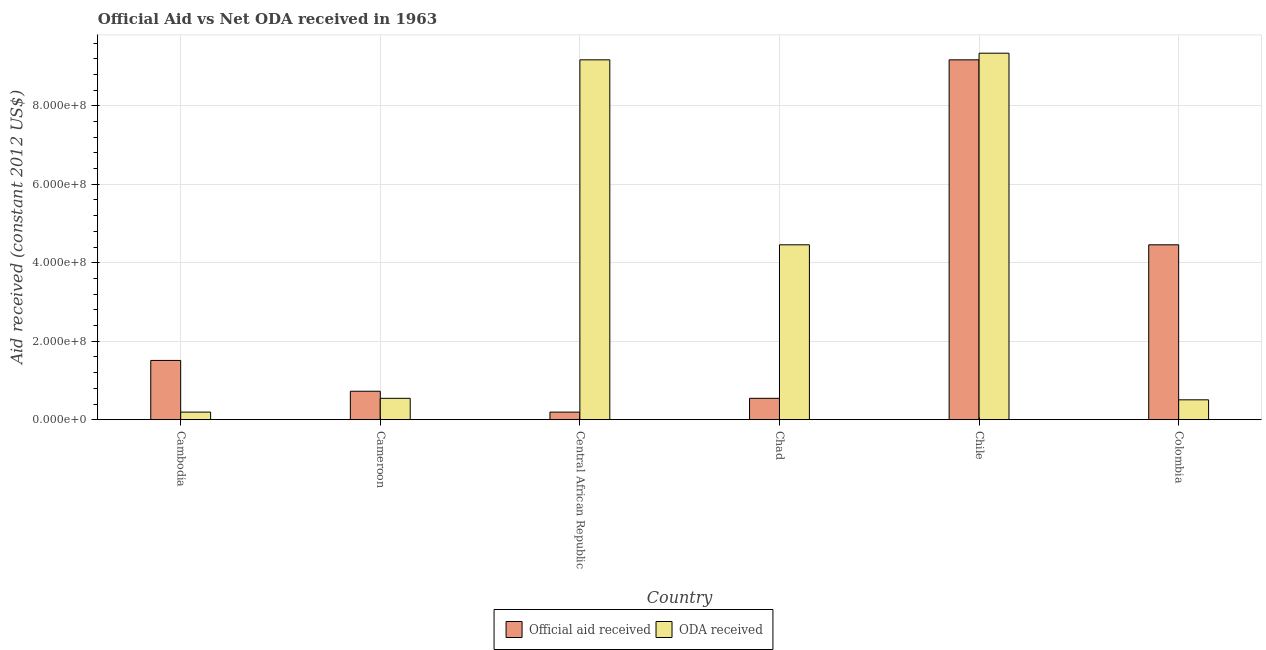How many different coloured bars are there?
Ensure brevity in your answer.  2. How many groups of bars are there?
Ensure brevity in your answer.  6. What is the label of the 4th group of bars from the left?
Keep it short and to the point. Chad. In how many cases, is the number of bars for a given country not equal to the number of legend labels?
Give a very brief answer. 0. What is the official aid received in Cambodia?
Make the answer very short. 1.51e+08. Across all countries, what is the maximum oda received?
Keep it short and to the point. 9.34e+08. Across all countries, what is the minimum official aid received?
Provide a succinct answer. 1.94e+07. In which country was the oda received maximum?
Offer a terse response. Chile. In which country was the official aid received minimum?
Your answer should be compact. Central African Republic. What is the total oda received in the graph?
Keep it short and to the point. 2.42e+09. What is the difference between the official aid received in Cambodia and that in Cameroon?
Your answer should be very brief. 7.85e+07. What is the difference between the oda received in Central African Republic and the official aid received in Colombia?
Provide a short and direct response. 4.71e+08. What is the average official aid received per country?
Your answer should be compact. 2.77e+08. What is the difference between the oda received and official aid received in Cambodia?
Give a very brief answer. -1.32e+08. What is the ratio of the oda received in Central African Republic to that in Chile?
Offer a terse response. 0.98. Is the difference between the official aid received in Central African Republic and Colombia greater than the difference between the oda received in Central African Republic and Colombia?
Your response must be concise. No. What is the difference between the highest and the second highest oda received?
Keep it short and to the point. 1.69e+07. What is the difference between the highest and the lowest official aid received?
Provide a short and direct response. 8.98e+08. In how many countries, is the official aid received greater than the average official aid received taken over all countries?
Provide a succinct answer. 2. Is the sum of the official aid received in Cambodia and Cameroon greater than the maximum oda received across all countries?
Ensure brevity in your answer.  No. What does the 1st bar from the left in Cambodia represents?
Offer a terse response. Official aid received. What does the 1st bar from the right in Central African Republic represents?
Give a very brief answer. ODA received. How many bars are there?
Offer a very short reply. 12. How many countries are there in the graph?
Keep it short and to the point. 6. What is the difference between two consecutive major ticks on the Y-axis?
Provide a short and direct response. 2.00e+08. Are the values on the major ticks of Y-axis written in scientific E-notation?
Offer a very short reply. Yes. Does the graph contain any zero values?
Your response must be concise. No. Does the graph contain grids?
Keep it short and to the point. Yes. Where does the legend appear in the graph?
Make the answer very short. Bottom center. How many legend labels are there?
Make the answer very short. 2. How are the legend labels stacked?
Ensure brevity in your answer.  Horizontal. What is the title of the graph?
Your answer should be compact. Official Aid vs Net ODA received in 1963 . What is the label or title of the X-axis?
Offer a very short reply. Country. What is the label or title of the Y-axis?
Your answer should be compact. Aid received (constant 2012 US$). What is the Aid received (constant 2012 US$) in Official aid received in Cambodia?
Offer a terse response. 1.51e+08. What is the Aid received (constant 2012 US$) of ODA received in Cambodia?
Offer a terse response. 1.94e+07. What is the Aid received (constant 2012 US$) of Official aid received in Cameroon?
Keep it short and to the point. 7.25e+07. What is the Aid received (constant 2012 US$) of ODA received in Cameroon?
Your response must be concise. 5.45e+07. What is the Aid received (constant 2012 US$) in Official aid received in Central African Republic?
Give a very brief answer. 1.94e+07. What is the Aid received (constant 2012 US$) in ODA received in Central African Republic?
Ensure brevity in your answer.  9.17e+08. What is the Aid received (constant 2012 US$) in Official aid received in Chad?
Your answer should be very brief. 5.45e+07. What is the Aid received (constant 2012 US$) in ODA received in Chad?
Give a very brief answer. 4.46e+08. What is the Aid received (constant 2012 US$) of Official aid received in Chile?
Keep it short and to the point. 9.17e+08. What is the Aid received (constant 2012 US$) of ODA received in Chile?
Ensure brevity in your answer.  9.34e+08. What is the Aid received (constant 2012 US$) of Official aid received in Colombia?
Offer a terse response. 4.46e+08. What is the Aid received (constant 2012 US$) in ODA received in Colombia?
Provide a succinct answer. 5.06e+07. Across all countries, what is the maximum Aid received (constant 2012 US$) in Official aid received?
Keep it short and to the point. 9.17e+08. Across all countries, what is the maximum Aid received (constant 2012 US$) in ODA received?
Make the answer very short. 9.34e+08. Across all countries, what is the minimum Aid received (constant 2012 US$) of Official aid received?
Ensure brevity in your answer.  1.94e+07. Across all countries, what is the minimum Aid received (constant 2012 US$) of ODA received?
Your answer should be very brief. 1.94e+07. What is the total Aid received (constant 2012 US$) of Official aid received in the graph?
Your answer should be compact. 1.66e+09. What is the total Aid received (constant 2012 US$) of ODA received in the graph?
Ensure brevity in your answer.  2.42e+09. What is the difference between the Aid received (constant 2012 US$) of Official aid received in Cambodia and that in Cameroon?
Your answer should be very brief. 7.85e+07. What is the difference between the Aid received (constant 2012 US$) in ODA received in Cambodia and that in Cameroon?
Provide a short and direct response. -3.51e+07. What is the difference between the Aid received (constant 2012 US$) of Official aid received in Cambodia and that in Central African Republic?
Your answer should be compact. 1.32e+08. What is the difference between the Aid received (constant 2012 US$) of ODA received in Cambodia and that in Central African Republic?
Make the answer very short. -8.98e+08. What is the difference between the Aid received (constant 2012 US$) in Official aid received in Cambodia and that in Chad?
Your answer should be very brief. 9.66e+07. What is the difference between the Aid received (constant 2012 US$) in ODA received in Cambodia and that in Chad?
Provide a short and direct response. -4.26e+08. What is the difference between the Aid received (constant 2012 US$) in Official aid received in Cambodia and that in Chile?
Keep it short and to the point. -7.66e+08. What is the difference between the Aid received (constant 2012 US$) in ODA received in Cambodia and that in Chile?
Keep it short and to the point. -9.15e+08. What is the difference between the Aid received (constant 2012 US$) in Official aid received in Cambodia and that in Colombia?
Provide a short and direct response. -2.95e+08. What is the difference between the Aid received (constant 2012 US$) of ODA received in Cambodia and that in Colombia?
Provide a succinct answer. -3.13e+07. What is the difference between the Aid received (constant 2012 US$) in Official aid received in Cameroon and that in Central African Republic?
Your response must be concise. 5.32e+07. What is the difference between the Aid received (constant 2012 US$) in ODA received in Cameroon and that in Central African Republic?
Your response must be concise. -8.63e+08. What is the difference between the Aid received (constant 2012 US$) of Official aid received in Cameroon and that in Chad?
Provide a succinct answer. 1.80e+07. What is the difference between the Aid received (constant 2012 US$) in ODA received in Cameroon and that in Chad?
Your answer should be very brief. -3.91e+08. What is the difference between the Aid received (constant 2012 US$) of Official aid received in Cameroon and that in Chile?
Ensure brevity in your answer.  -8.45e+08. What is the difference between the Aid received (constant 2012 US$) in ODA received in Cameroon and that in Chile?
Your answer should be compact. -8.80e+08. What is the difference between the Aid received (constant 2012 US$) in Official aid received in Cameroon and that in Colombia?
Your answer should be very brief. -3.73e+08. What is the difference between the Aid received (constant 2012 US$) in ODA received in Cameroon and that in Colombia?
Ensure brevity in your answer.  3.82e+06. What is the difference between the Aid received (constant 2012 US$) of Official aid received in Central African Republic and that in Chad?
Give a very brief answer. -3.51e+07. What is the difference between the Aid received (constant 2012 US$) of ODA received in Central African Republic and that in Chad?
Offer a terse response. 4.71e+08. What is the difference between the Aid received (constant 2012 US$) in Official aid received in Central African Republic and that in Chile?
Your answer should be very brief. -8.98e+08. What is the difference between the Aid received (constant 2012 US$) of ODA received in Central African Republic and that in Chile?
Give a very brief answer. -1.69e+07. What is the difference between the Aid received (constant 2012 US$) in Official aid received in Central African Republic and that in Colombia?
Your answer should be very brief. -4.26e+08. What is the difference between the Aid received (constant 2012 US$) of ODA received in Central African Republic and that in Colombia?
Provide a short and direct response. 8.67e+08. What is the difference between the Aid received (constant 2012 US$) in Official aid received in Chad and that in Chile?
Give a very brief answer. -8.63e+08. What is the difference between the Aid received (constant 2012 US$) in ODA received in Chad and that in Chile?
Your answer should be very brief. -4.88e+08. What is the difference between the Aid received (constant 2012 US$) of Official aid received in Chad and that in Colombia?
Make the answer very short. -3.91e+08. What is the difference between the Aid received (constant 2012 US$) of ODA received in Chad and that in Colombia?
Make the answer very short. 3.95e+08. What is the difference between the Aid received (constant 2012 US$) in Official aid received in Chile and that in Colombia?
Provide a succinct answer. 4.71e+08. What is the difference between the Aid received (constant 2012 US$) in ODA received in Chile and that in Colombia?
Your response must be concise. 8.83e+08. What is the difference between the Aid received (constant 2012 US$) in Official aid received in Cambodia and the Aid received (constant 2012 US$) in ODA received in Cameroon?
Make the answer very short. 9.66e+07. What is the difference between the Aid received (constant 2012 US$) in Official aid received in Cambodia and the Aid received (constant 2012 US$) in ODA received in Central African Republic?
Your response must be concise. -7.66e+08. What is the difference between the Aid received (constant 2012 US$) of Official aid received in Cambodia and the Aid received (constant 2012 US$) of ODA received in Chad?
Keep it short and to the point. -2.95e+08. What is the difference between the Aid received (constant 2012 US$) of Official aid received in Cambodia and the Aid received (constant 2012 US$) of ODA received in Chile?
Provide a short and direct response. -7.83e+08. What is the difference between the Aid received (constant 2012 US$) of Official aid received in Cambodia and the Aid received (constant 2012 US$) of ODA received in Colombia?
Your answer should be compact. 1.00e+08. What is the difference between the Aid received (constant 2012 US$) of Official aid received in Cameroon and the Aid received (constant 2012 US$) of ODA received in Central African Republic?
Keep it short and to the point. -8.45e+08. What is the difference between the Aid received (constant 2012 US$) in Official aid received in Cameroon and the Aid received (constant 2012 US$) in ODA received in Chad?
Offer a terse response. -3.73e+08. What is the difference between the Aid received (constant 2012 US$) in Official aid received in Cameroon and the Aid received (constant 2012 US$) in ODA received in Chile?
Make the answer very short. -8.62e+08. What is the difference between the Aid received (constant 2012 US$) of Official aid received in Cameroon and the Aid received (constant 2012 US$) of ODA received in Colombia?
Give a very brief answer. 2.19e+07. What is the difference between the Aid received (constant 2012 US$) of Official aid received in Central African Republic and the Aid received (constant 2012 US$) of ODA received in Chad?
Provide a succinct answer. -4.26e+08. What is the difference between the Aid received (constant 2012 US$) in Official aid received in Central African Republic and the Aid received (constant 2012 US$) in ODA received in Chile?
Provide a succinct answer. -9.15e+08. What is the difference between the Aid received (constant 2012 US$) in Official aid received in Central African Republic and the Aid received (constant 2012 US$) in ODA received in Colombia?
Ensure brevity in your answer.  -3.13e+07. What is the difference between the Aid received (constant 2012 US$) of Official aid received in Chad and the Aid received (constant 2012 US$) of ODA received in Chile?
Your answer should be compact. -8.80e+08. What is the difference between the Aid received (constant 2012 US$) in Official aid received in Chad and the Aid received (constant 2012 US$) in ODA received in Colombia?
Offer a very short reply. 3.82e+06. What is the difference between the Aid received (constant 2012 US$) of Official aid received in Chile and the Aid received (constant 2012 US$) of ODA received in Colombia?
Give a very brief answer. 8.67e+08. What is the average Aid received (constant 2012 US$) in Official aid received per country?
Offer a very short reply. 2.77e+08. What is the average Aid received (constant 2012 US$) of ODA received per country?
Your response must be concise. 4.04e+08. What is the difference between the Aid received (constant 2012 US$) in Official aid received and Aid received (constant 2012 US$) in ODA received in Cambodia?
Your response must be concise. 1.32e+08. What is the difference between the Aid received (constant 2012 US$) in Official aid received and Aid received (constant 2012 US$) in ODA received in Cameroon?
Your answer should be very brief. 1.80e+07. What is the difference between the Aid received (constant 2012 US$) in Official aid received and Aid received (constant 2012 US$) in ODA received in Central African Republic?
Your answer should be very brief. -8.98e+08. What is the difference between the Aid received (constant 2012 US$) in Official aid received and Aid received (constant 2012 US$) in ODA received in Chad?
Your response must be concise. -3.91e+08. What is the difference between the Aid received (constant 2012 US$) of Official aid received and Aid received (constant 2012 US$) of ODA received in Chile?
Provide a succinct answer. -1.69e+07. What is the difference between the Aid received (constant 2012 US$) of Official aid received and Aid received (constant 2012 US$) of ODA received in Colombia?
Make the answer very short. 3.95e+08. What is the ratio of the Aid received (constant 2012 US$) of Official aid received in Cambodia to that in Cameroon?
Provide a short and direct response. 2.08. What is the ratio of the Aid received (constant 2012 US$) of ODA received in Cambodia to that in Cameroon?
Offer a terse response. 0.36. What is the ratio of the Aid received (constant 2012 US$) of Official aid received in Cambodia to that in Central African Republic?
Your answer should be very brief. 7.8. What is the ratio of the Aid received (constant 2012 US$) of ODA received in Cambodia to that in Central African Republic?
Provide a short and direct response. 0.02. What is the ratio of the Aid received (constant 2012 US$) in Official aid received in Cambodia to that in Chad?
Give a very brief answer. 2.77. What is the ratio of the Aid received (constant 2012 US$) in ODA received in Cambodia to that in Chad?
Ensure brevity in your answer.  0.04. What is the ratio of the Aid received (constant 2012 US$) of Official aid received in Cambodia to that in Chile?
Your answer should be very brief. 0.16. What is the ratio of the Aid received (constant 2012 US$) of ODA received in Cambodia to that in Chile?
Provide a short and direct response. 0.02. What is the ratio of the Aid received (constant 2012 US$) in Official aid received in Cambodia to that in Colombia?
Your answer should be very brief. 0.34. What is the ratio of the Aid received (constant 2012 US$) in ODA received in Cambodia to that in Colombia?
Your response must be concise. 0.38. What is the ratio of the Aid received (constant 2012 US$) in Official aid received in Cameroon to that in Central African Republic?
Your answer should be very brief. 3.74. What is the ratio of the Aid received (constant 2012 US$) in ODA received in Cameroon to that in Central African Republic?
Your response must be concise. 0.06. What is the ratio of the Aid received (constant 2012 US$) of Official aid received in Cameroon to that in Chad?
Provide a short and direct response. 1.33. What is the ratio of the Aid received (constant 2012 US$) in ODA received in Cameroon to that in Chad?
Offer a terse response. 0.12. What is the ratio of the Aid received (constant 2012 US$) in Official aid received in Cameroon to that in Chile?
Offer a terse response. 0.08. What is the ratio of the Aid received (constant 2012 US$) in ODA received in Cameroon to that in Chile?
Offer a terse response. 0.06. What is the ratio of the Aid received (constant 2012 US$) in Official aid received in Cameroon to that in Colombia?
Give a very brief answer. 0.16. What is the ratio of the Aid received (constant 2012 US$) in ODA received in Cameroon to that in Colombia?
Provide a succinct answer. 1.08. What is the ratio of the Aid received (constant 2012 US$) in Official aid received in Central African Republic to that in Chad?
Offer a very short reply. 0.36. What is the ratio of the Aid received (constant 2012 US$) in ODA received in Central African Republic to that in Chad?
Your answer should be very brief. 2.06. What is the ratio of the Aid received (constant 2012 US$) in Official aid received in Central African Republic to that in Chile?
Keep it short and to the point. 0.02. What is the ratio of the Aid received (constant 2012 US$) in ODA received in Central African Republic to that in Chile?
Your answer should be compact. 0.98. What is the ratio of the Aid received (constant 2012 US$) in Official aid received in Central African Republic to that in Colombia?
Provide a short and direct response. 0.04. What is the ratio of the Aid received (constant 2012 US$) of ODA received in Central African Republic to that in Colombia?
Your answer should be compact. 18.11. What is the ratio of the Aid received (constant 2012 US$) in Official aid received in Chad to that in Chile?
Your answer should be compact. 0.06. What is the ratio of the Aid received (constant 2012 US$) of ODA received in Chad to that in Chile?
Your answer should be very brief. 0.48. What is the ratio of the Aid received (constant 2012 US$) of Official aid received in Chad to that in Colombia?
Provide a succinct answer. 0.12. What is the ratio of the Aid received (constant 2012 US$) in ODA received in Chad to that in Colombia?
Your response must be concise. 8.8. What is the ratio of the Aid received (constant 2012 US$) of Official aid received in Chile to that in Colombia?
Provide a short and direct response. 2.06. What is the ratio of the Aid received (constant 2012 US$) in ODA received in Chile to that in Colombia?
Your answer should be very brief. 18.44. What is the difference between the highest and the second highest Aid received (constant 2012 US$) of Official aid received?
Keep it short and to the point. 4.71e+08. What is the difference between the highest and the second highest Aid received (constant 2012 US$) in ODA received?
Ensure brevity in your answer.  1.69e+07. What is the difference between the highest and the lowest Aid received (constant 2012 US$) in Official aid received?
Offer a terse response. 8.98e+08. What is the difference between the highest and the lowest Aid received (constant 2012 US$) in ODA received?
Keep it short and to the point. 9.15e+08. 